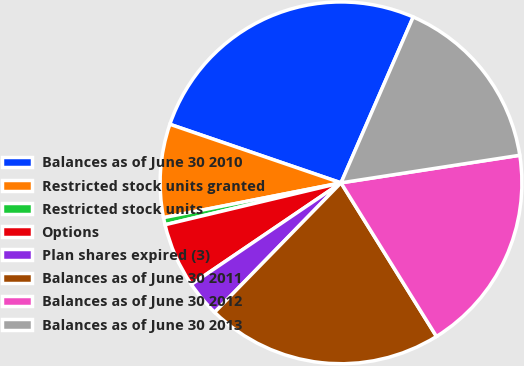Convert chart. <chart><loc_0><loc_0><loc_500><loc_500><pie_chart><fcel>Balances as of June 30 2010<fcel>Restricted stock units granted<fcel>Restricted stock units<fcel>Options<fcel>Plan shares expired (3)<fcel>Balances as of June 30 2011<fcel>Balances as of June 30 2012<fcel>Balances as of June 30 2013<nl><fcel>26.29%<fcel>8.33%<fcel>0.64%<fcel>5.77%<fcel>3.2%<fcel>21.16%<fcel>18.59%<fcel>16.03%<nl></chart> 